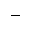<formula> <loc_0><loc_0><loc_500><loc_500>^ { - }</formula> 